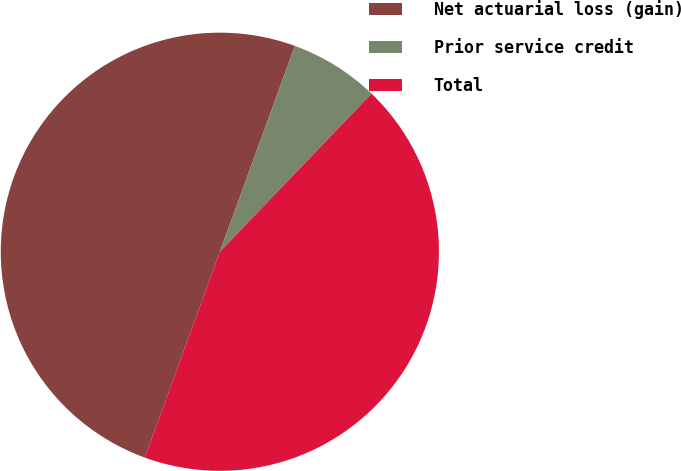<chart> <loc_0><loc_0><loc_500><loc_500><pie_chart><fcel>Net actuarial loss (gain)<fcel>Prior service credit<fcel>Total<nl><fcel>50.0%<fcel>6.61%<fcel>43.39%<nl></chart> 